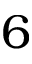<formula> <loc_0><loc_0><loc_500><loc_500>6</formula> 